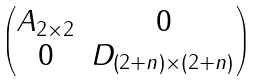<formula> <loc_0><loc_0><loc_500><loc_500>\begin{pmatrix} A _ { 2 \times 2 } & 0 \\ 0 & D _ { ( 2 + n ) \times ( 2 + n ) } \end{pmatrix}</formula> 